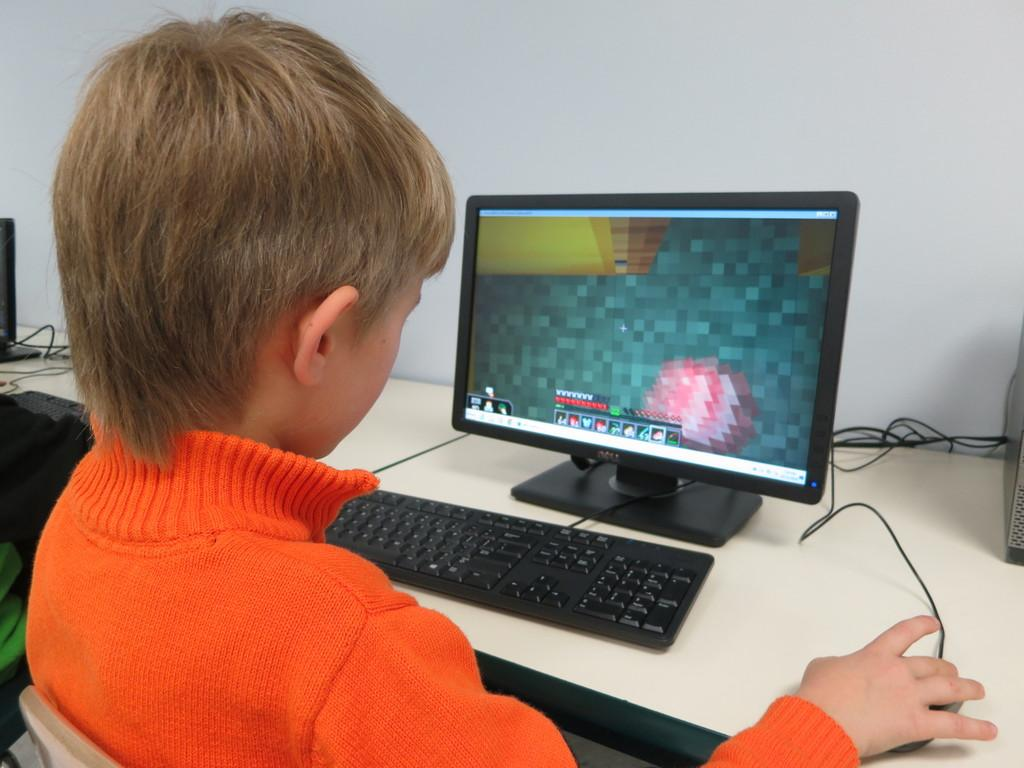Provide a one-sentence caption for the provided image. A boy in an orange shirt plays a computer game on a Dell computer. 